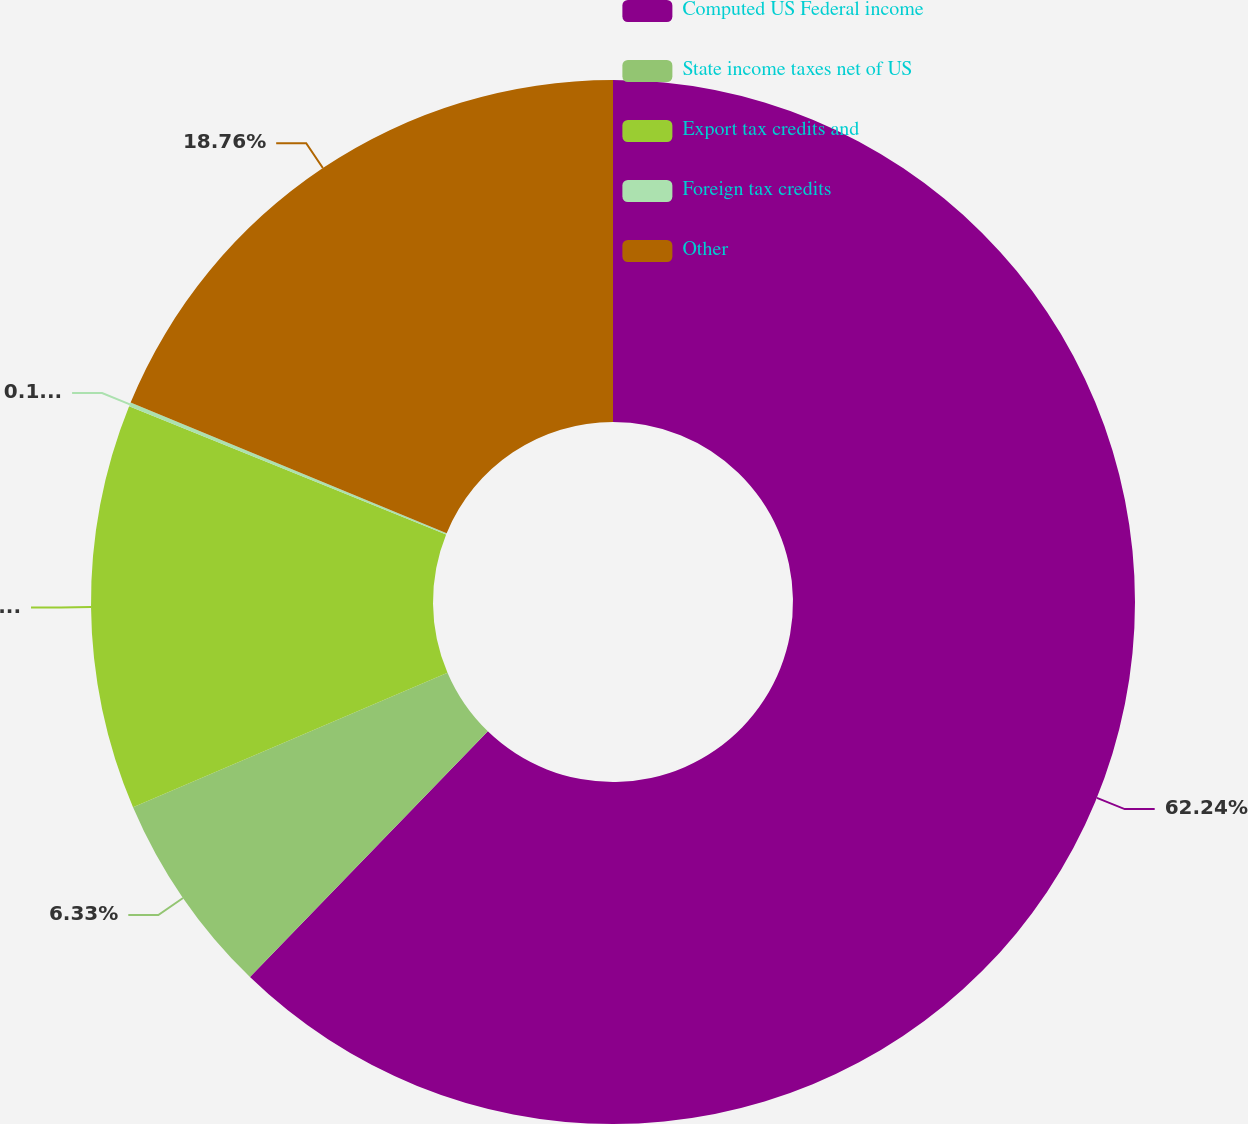<chart> <loc_0><loc_0><loc_500><loc_500><pie_chart><fcel>Computed US Federal income<fcel>State income taxes net of US<fcel>Export tax credits and<fcel>Foreign tax credits<fcel>Other<nl><fcel>62.24%<fcel>6.33%<fcel>12.55%<fcel>0.12%<fcel>18.76%<nl></chart> 